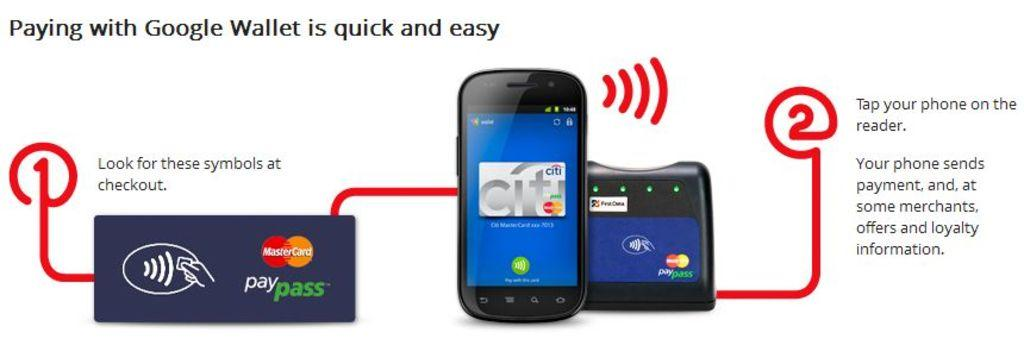Provide a one-sentence caption for the provided image. An Google Wallet infographic shows how easy it is to pay with Google Wallet. 